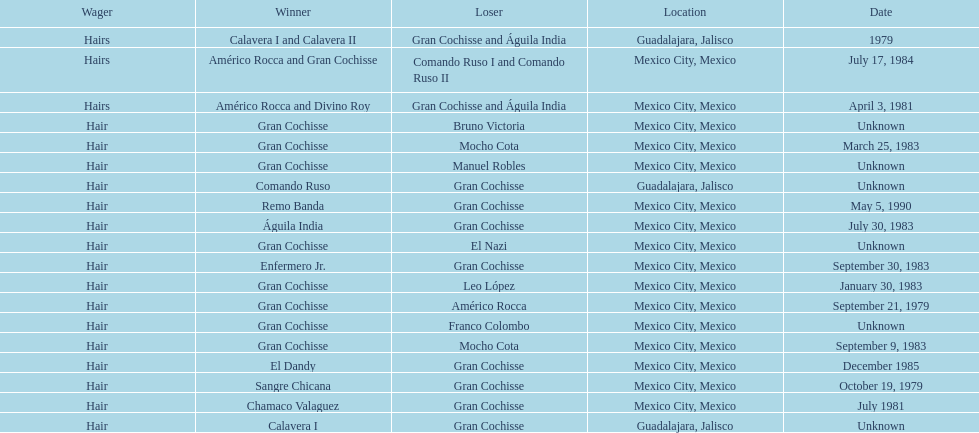How many times has gran cochisse been a winner? 9. 